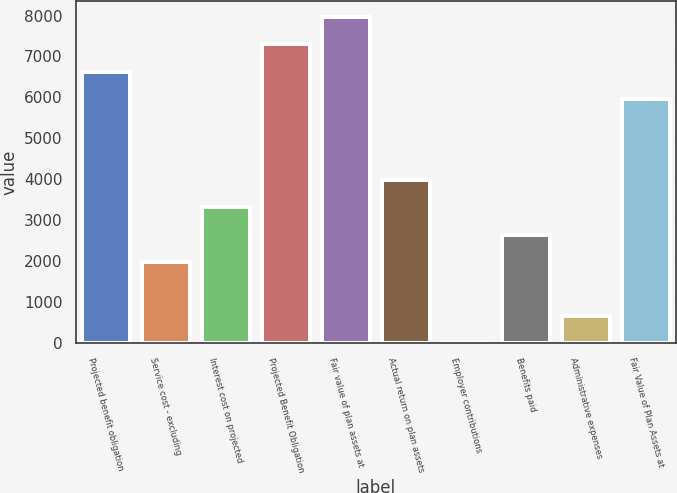<chart> <loc_0><loc_0><loc_500><loc_500><bar_chart><fcel>Projected benefit obligation<fcel>Service cost - excluding<fcel>Interest cost on projected<fcel>Projected Benefit Obligation<fcel>Fair value of plan assets at<fcel>Actual return on plan assets<fcel>Employer contributions<fcel>Benefits paid<fcel>Administrative expenses<fcel>Fair Value of Plan Assets at<nl><fcel>6633<fcel>1992.7<fcel>3318.5<fcel>7295.9<fcel>7958.8<fcel>3981.4<fcel>4<fcel>2655.6<fcel>666.9<fcel>5970.1<nl></chart> 